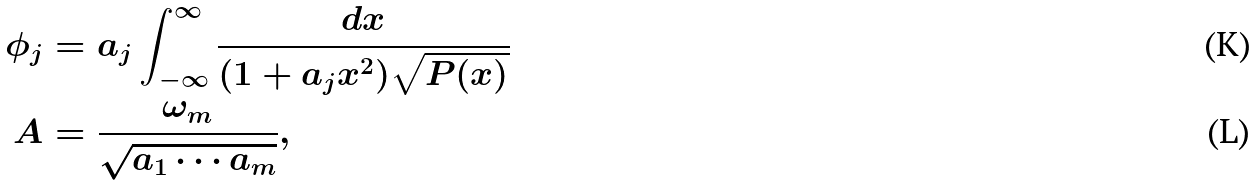Convert formula to latex. <formula><loc_0><loc_0><loc_500><loc_500>\phi _ { j } & = a _ { j } \int _ { - \infty } ^ { \infty } \frac { d x } { ( 1 + a _ { j } x ^ { 2 } ) \sqrt { P ( x ) } } \\ A & = \frac { \omega _ { m } } { \sqrt { a _ { 1 } \cdots a _ { m } } } ,</formula> 